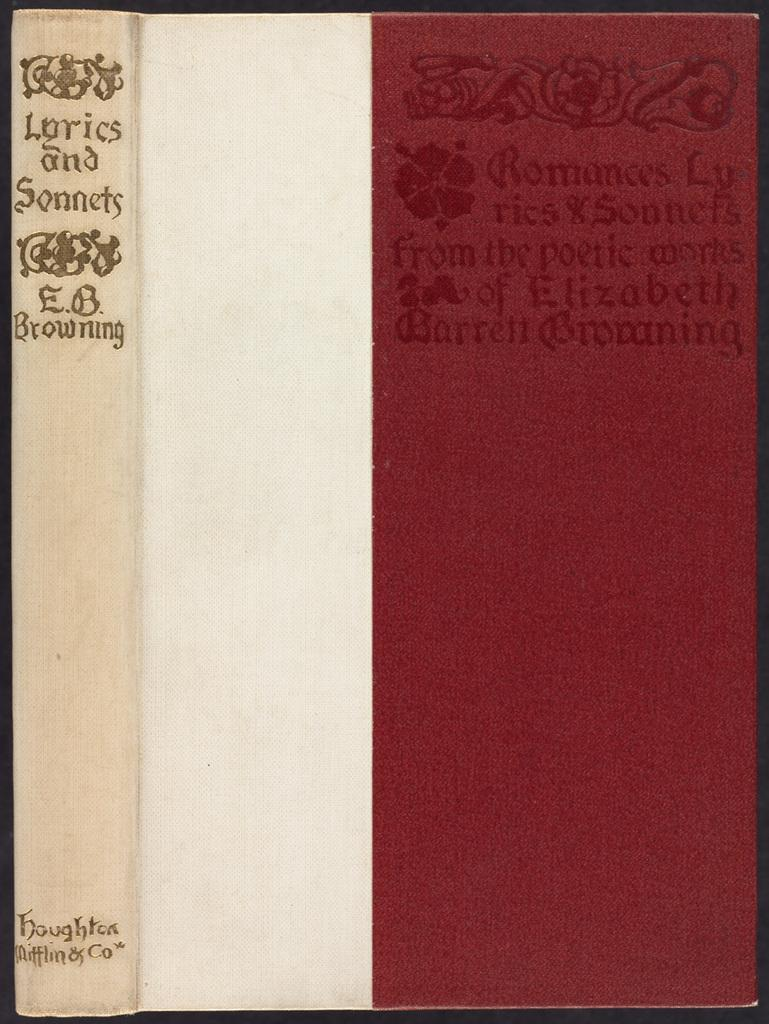<image>
Offer a succinct explanation of the picture presented. A book about lyrics and sonnets by E.B. Browning. 